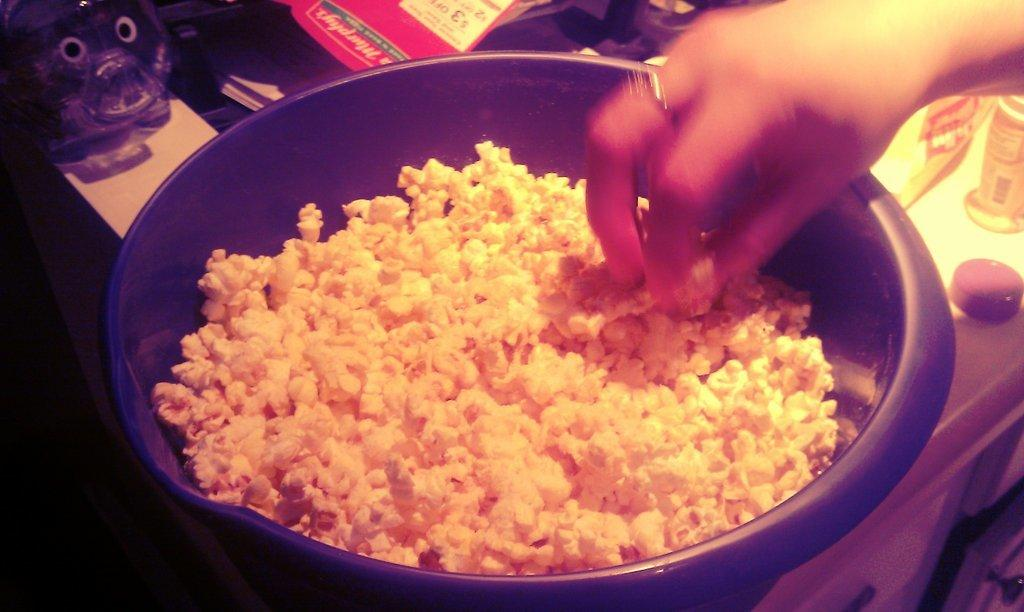What is in the bowl that is visible in the image? There is a bowl with food in the image. What else can be seen in the image besides the bowl of food? There are papers visible in the image. Who is holding the food in the image? There is a person holding the food in the image. What can be observed about the surface in the image? There are many objects on the surface in the image. What time does the clock show in the image? There is no clock present in the image, so it is not possible to determine the time. 